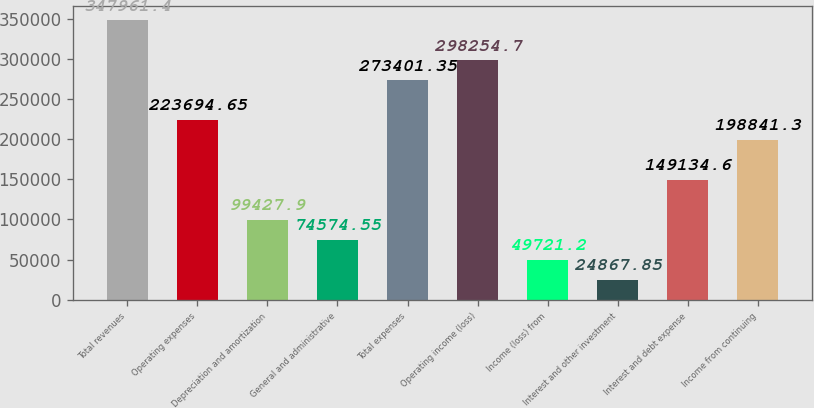Convert chart to OTSL. <chart><loc_0><loc_0><loc_500><loc_500><bar_chart><fcel>Total revenues<fcel>Operating expenses<fcel>Depreciation and amortization<fcel>General and administrative<fcel>Total expenses<fcel>Operating income (loss)<fcel>Income (loss) from<fcel>Interest and other investment<fcel>Interest and debt expense<fcel>Income from continuing<nl><fcel>347961<fcel>223695<fcel>99427.9<fcel>74574.6<fcel>273401<fcel>298255<fcel>49721.2<fcel>24867.8<fcel>149135<fcel>198841<nl></chart> 